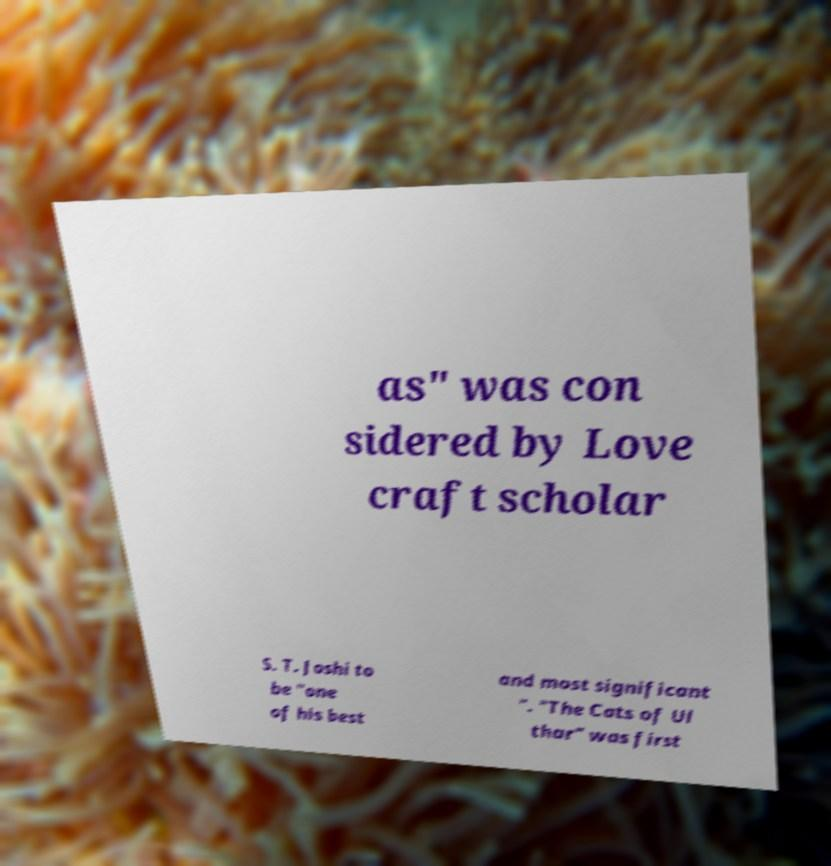Can you read and provide the text displayed in the image?This photo seems to have some interesting text. Can you extract and type it out for me? as" was con sidered by Love craft scholar S. T. Joshi to be "one of his best and most significant ". "The Cats of Ul thar" was first 